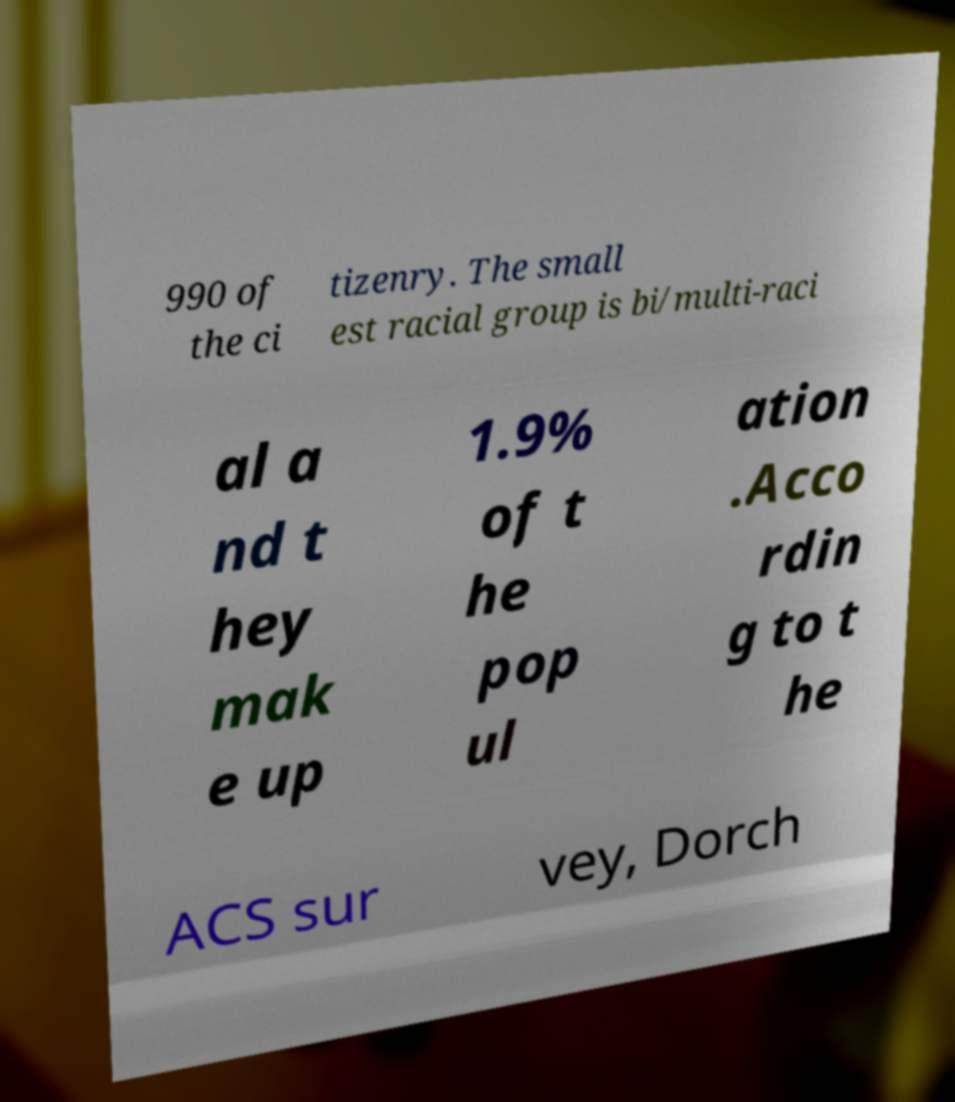Can you accurately transcribe the text from the provided image for me? 990 of the ci tizenry. The small est racial group is bi/multi-raci al a nd t hey mak e up 1.9% of t he pop ul ation .Acco rdin g to t he ACS sur vey, Dorch 